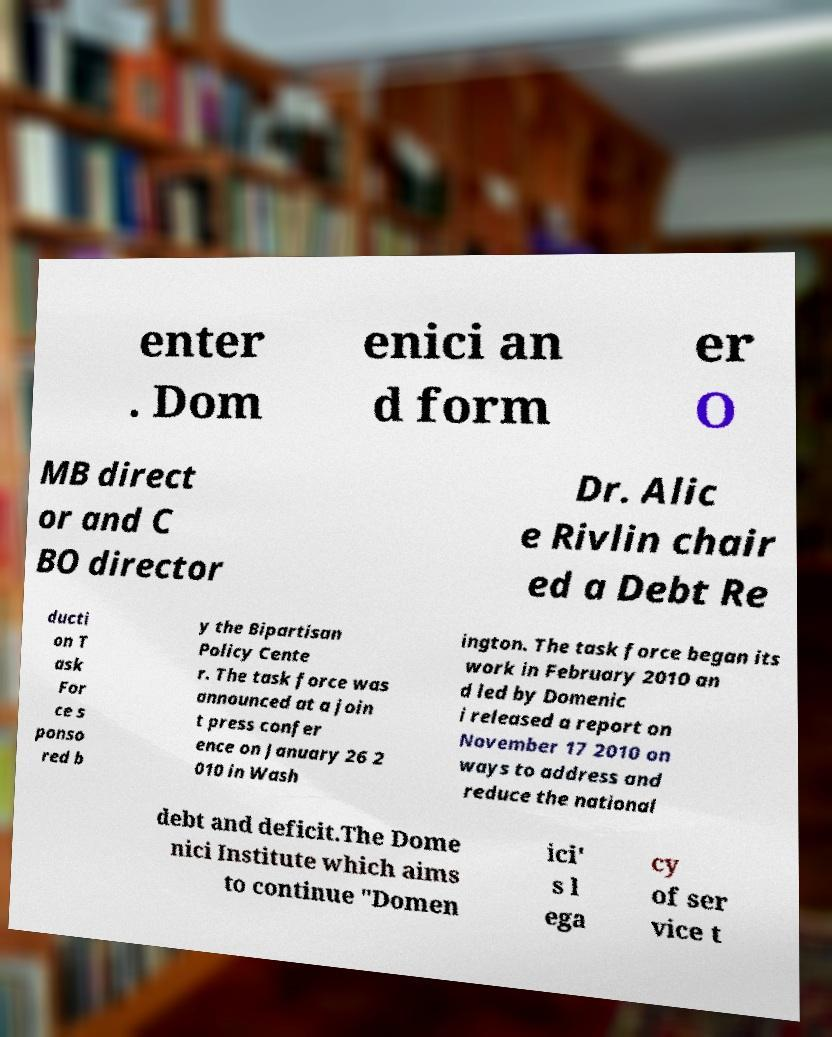What messages or text are displayed in this image? I need them in a readable, typed format. enter . Dom enici an d form er O MB direct or and C BO director Dr. Alic e Rivlin chair ed a Debt Re ducti on T ask For ce s ponso red b y the Bipartisan Policy Cente r. The task force was announced at a join t press confer ence on January 26 2 010 in Wash ington. The task force began its work in February 2010 an d led by Domenic i released a report on November 17 2010 on ways to address and reduce the national debt and deficit.The Dome nici Institute which aims to continue "Domen ici' s l ega cy of ser vice t 